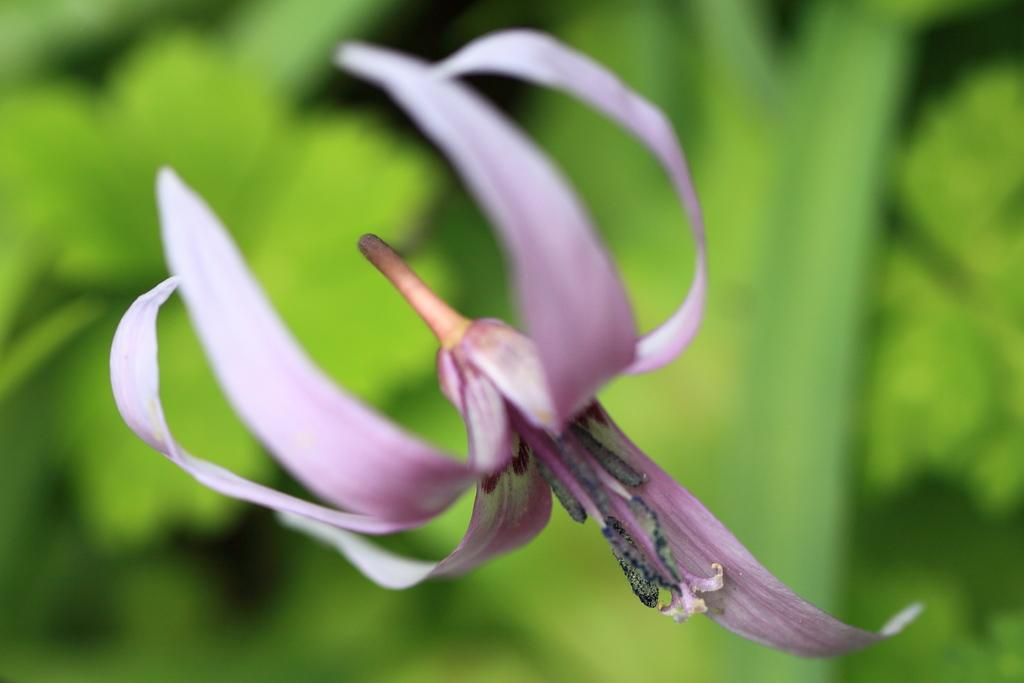What is the main subject of the image? There is a flower in the image. Can you describe the background of the image? The background of the image is blurred. How many buckets are used to measure the flower in the image? There are no buckets present in the image, and the flower is not being measured. What type of parcel is being delivered to the flower in the image? There is no parcel or delivery depicted in the image; it only features a flower and a blurred background. 